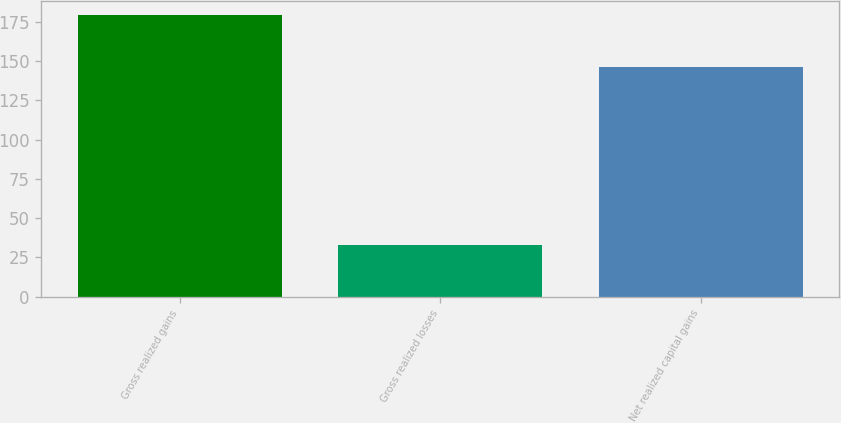Convert chart. <chart><loc_0><loc_0><loc_500><loc_500><bar_chart><fcel>Gross realized gains<fcel>Gross realized losses<fcel>Net realized capital gains<nl><fcel>179<fcel>33<fcel>146<nl></chart> 